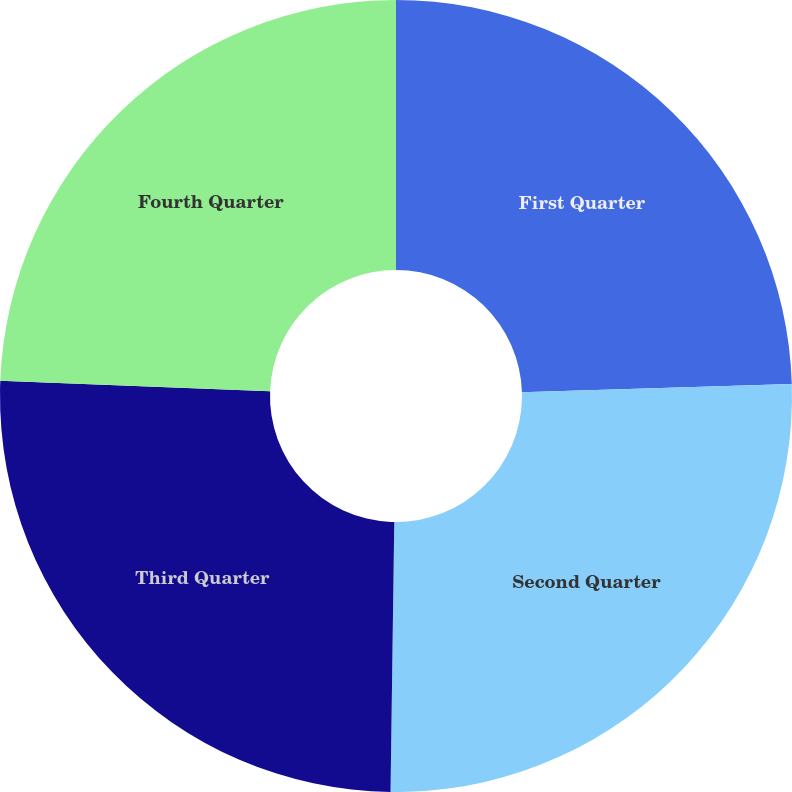Convert chart. <chart><loc_0><loc_0><loc_500><loc_500><pie_chart><fcel>First Quarter<fcel>Second Quarter<fcel>Third Quarter<fcel>Fourth Quarter<nl><fcel>24.52%<fcel>25.7%<fcel>25.39%<fcel>24.39%<nl></chart> 